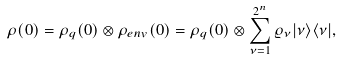Convert formula to latex. <formula><loc_0><loc_0><loc_500><loc_500>\rho ( 0 ) = \rho _ { q } ( 0 ) \otimes \rho _ { e n v } ( 0 ) = \rho _ { q } ( 0 ) \otimes \sum _ { \nu = 1 } ^ { 2 ^ { n } } \varrho _ { \nu } | \nu \rangle \langle \nu | ,</formula> 